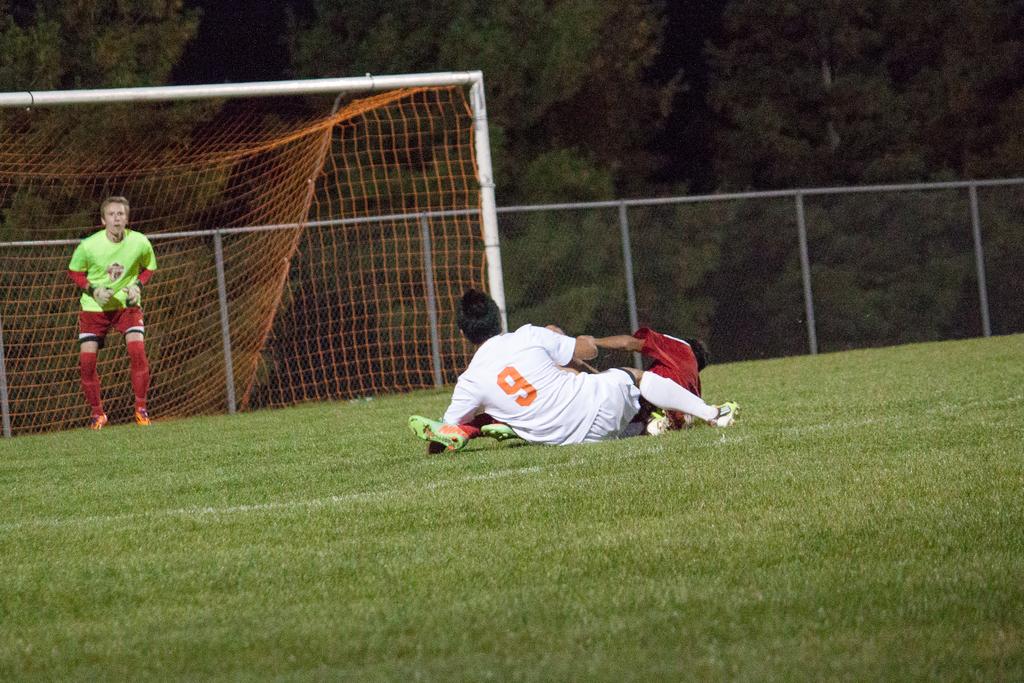What is the number of the guy on the ground?
Provide a short and direct response. 9. 